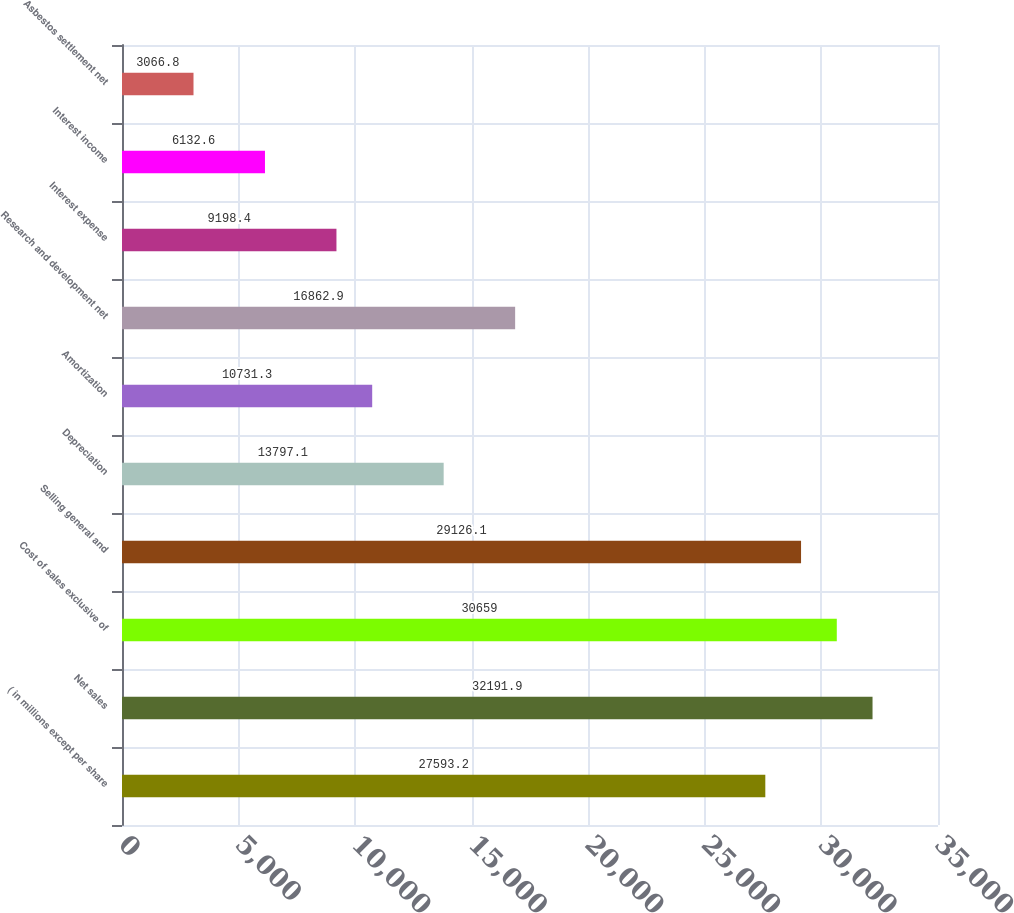Convert chart. <chart><loc_0><loc_0><loc_500><loc_500><bar_chart><fcel>( in millions except per share<fcel>Net sales<fcel>Cost of sales exclusive of<fcel>Selling general and<fcel>Depreciation<fcel>Amortization<fcel>Research and development net<fcel>Interest expense<fcel>Interest income<fcel>Asbestos settlement net<nl><fcel>27593.2<fcel>32191.9<fcel>30659<fcel>29126.1<fcel>13797.1<fcel>10731.3<fcel>16862.9<fcel>9198.4<fcel>6132.6<fcel>3066.8<nl></chart> 